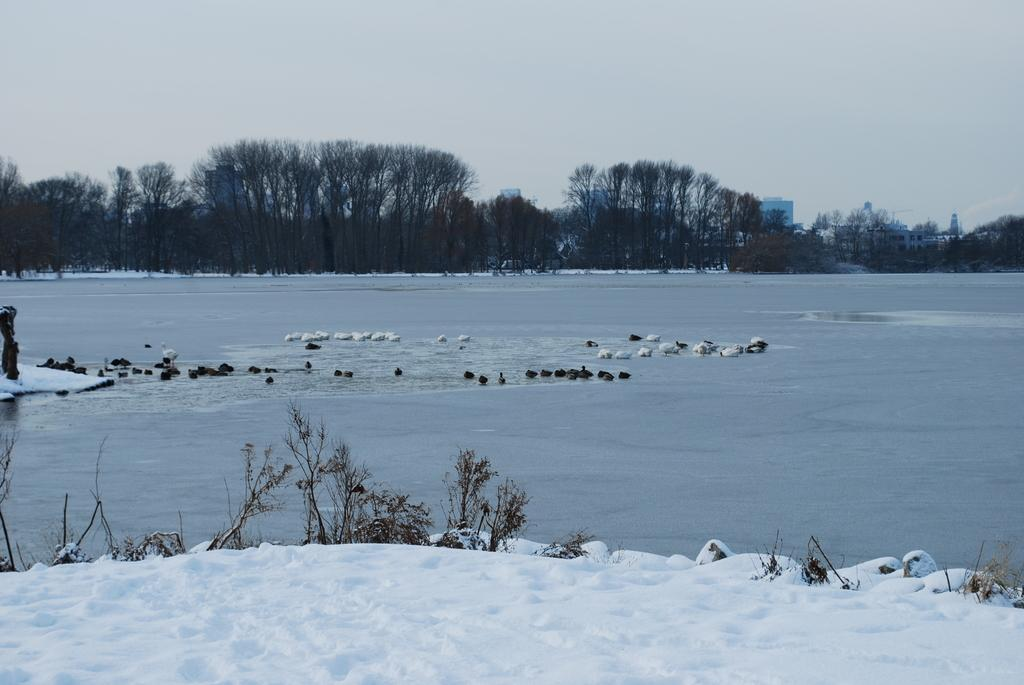What type of living organisms can be seen in the image? Plants and birds are visible in the image. What is the weather like in the image? There is snow in the image, indicating a cold and likely wintery weather. What can be seen in the water in the image? The provided facts do not specify anything about the water in the image. What is visible in the background of the image? Trees, buildings, and the sky are visible in the background of the image. What type of belief system is represented by the engine in the image? There is no engine present in the image, so it is not possible to determine any belief system associated with it. 